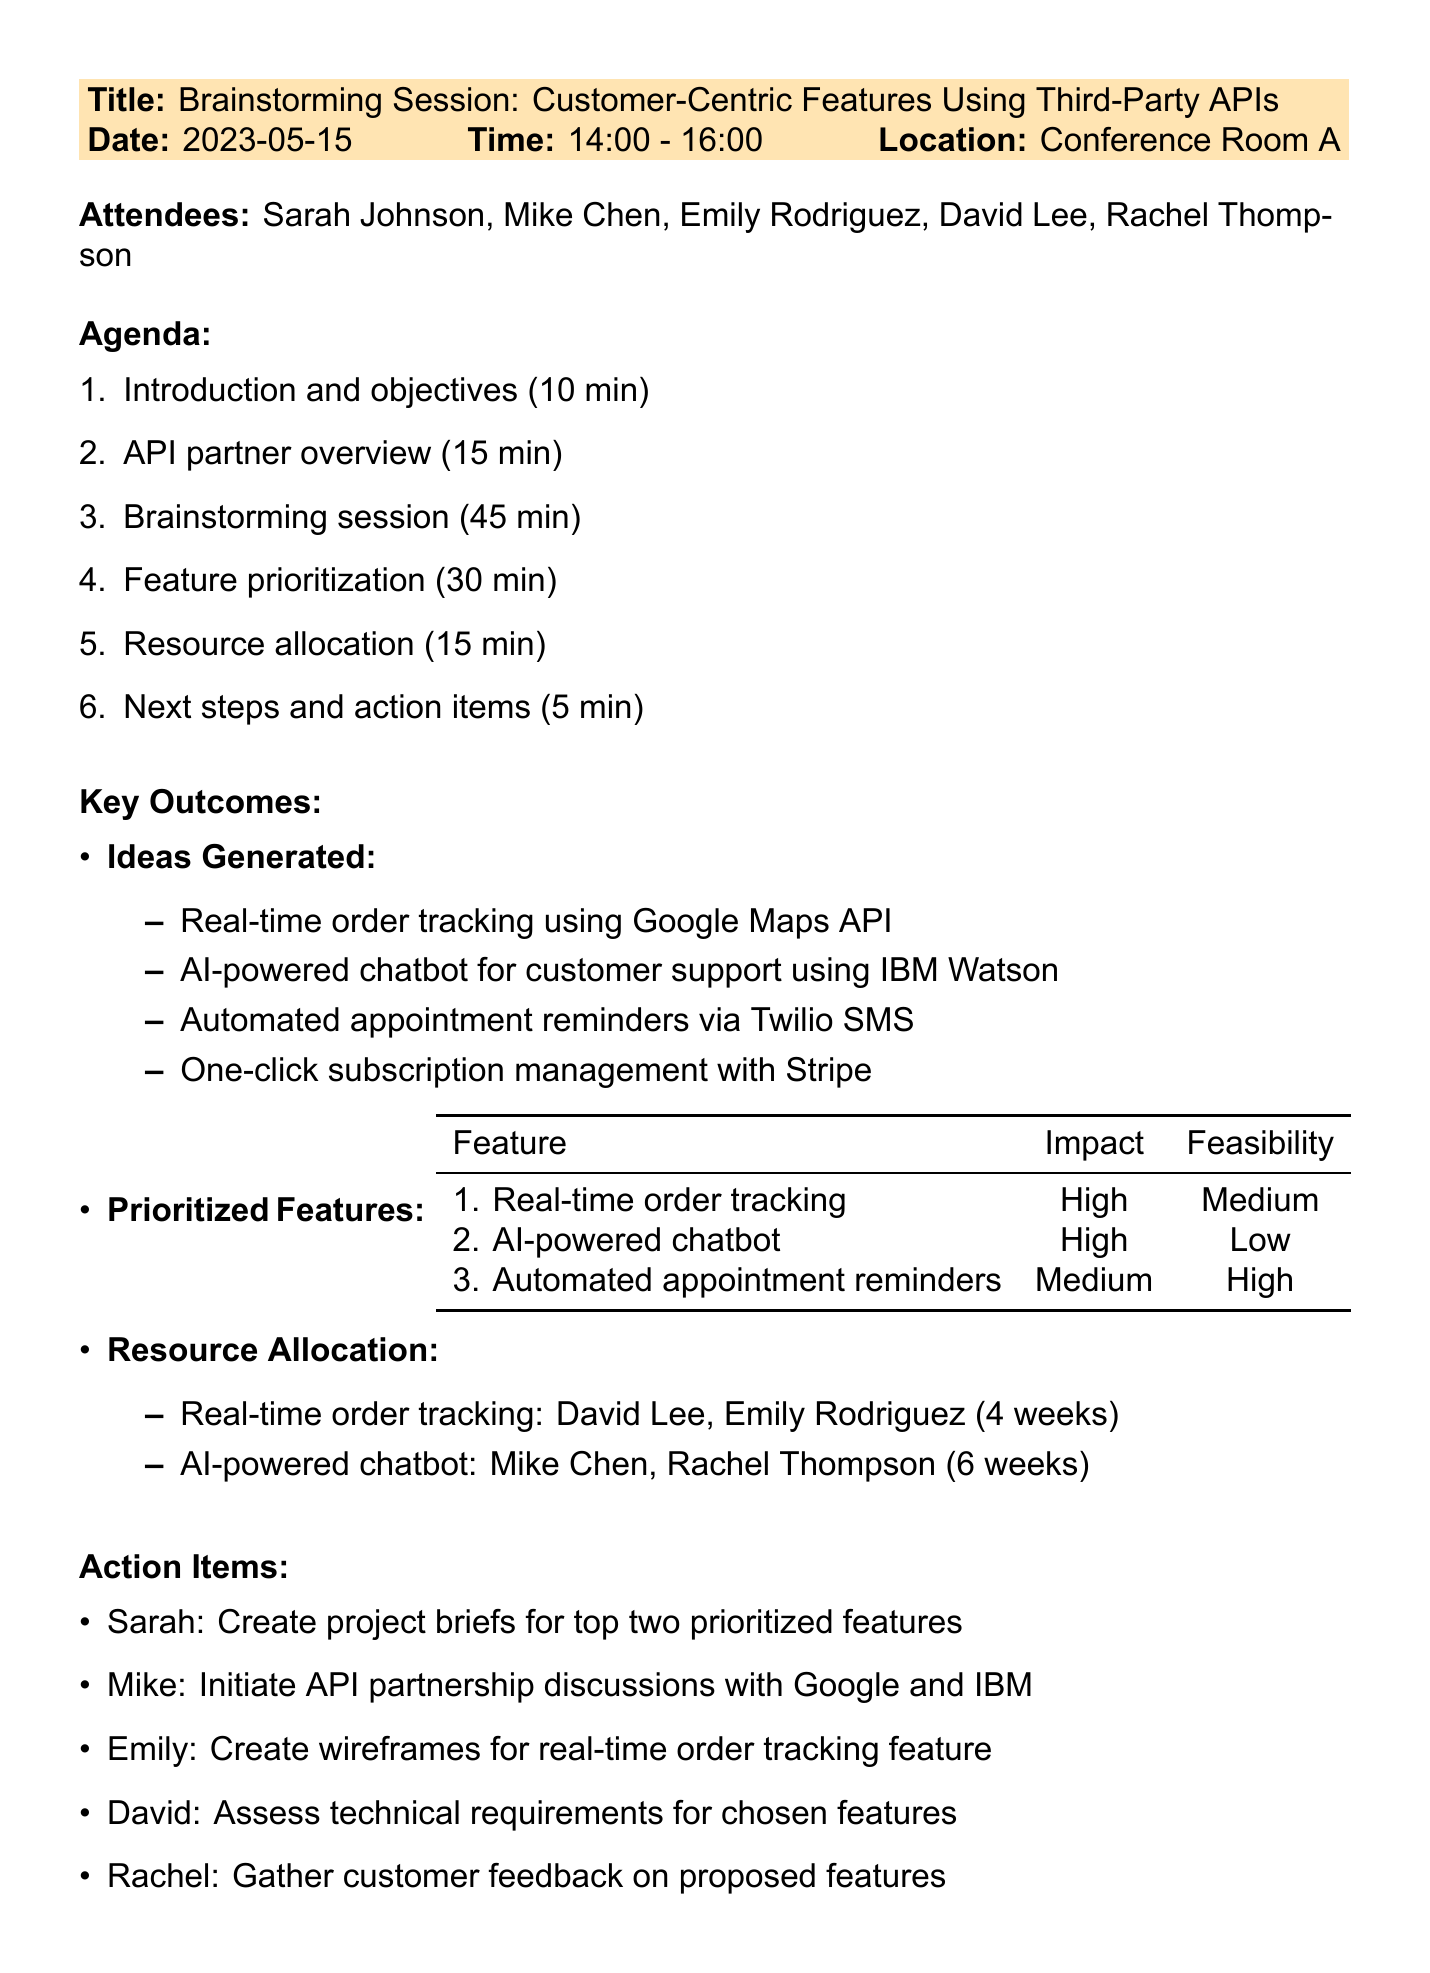What is the title of the meeting? The title of the meeting is specified in the meeting details section of the document.
Answer: Brainstorming Session: Customer-Centric Features Using Third-Party APIs Who is the API Integration Specialist? The API Integration Specialist is listed in the attendees section of the document.
Answer: Mike Chen How long was the brainstorming session? The duration of the brainstorming session can be found under the agenda items section.
Answer: 45 minutes What is the priority level of the "AI-powered chatbot"? The priority level is mentioned in the feature prioritization section of the document.
Answer: 2 Which feature requires 4 weeks for development? The estimated time for development of each feature is listed under the resource allocation section.
Answer: Real-time order tracking What are Sarah's responsibilities following the meeting? Sarah's action item is mentioned in the next steps section of the document.
Answer: Create project briefs for top two prioritized features How many attendees were present in the meeting? The total number of attendees can be counted from the attendees section.
Answer: 5 Which API provides payment processing services? The API partners are listed in the API partner overview section, specifying their services.
Answer: Stripe What is the overall objective of the meeting? The main objective is outlined in the introduction and objectives section of the document.
Answer: Improve customer satisfaction through innovative API integrations 